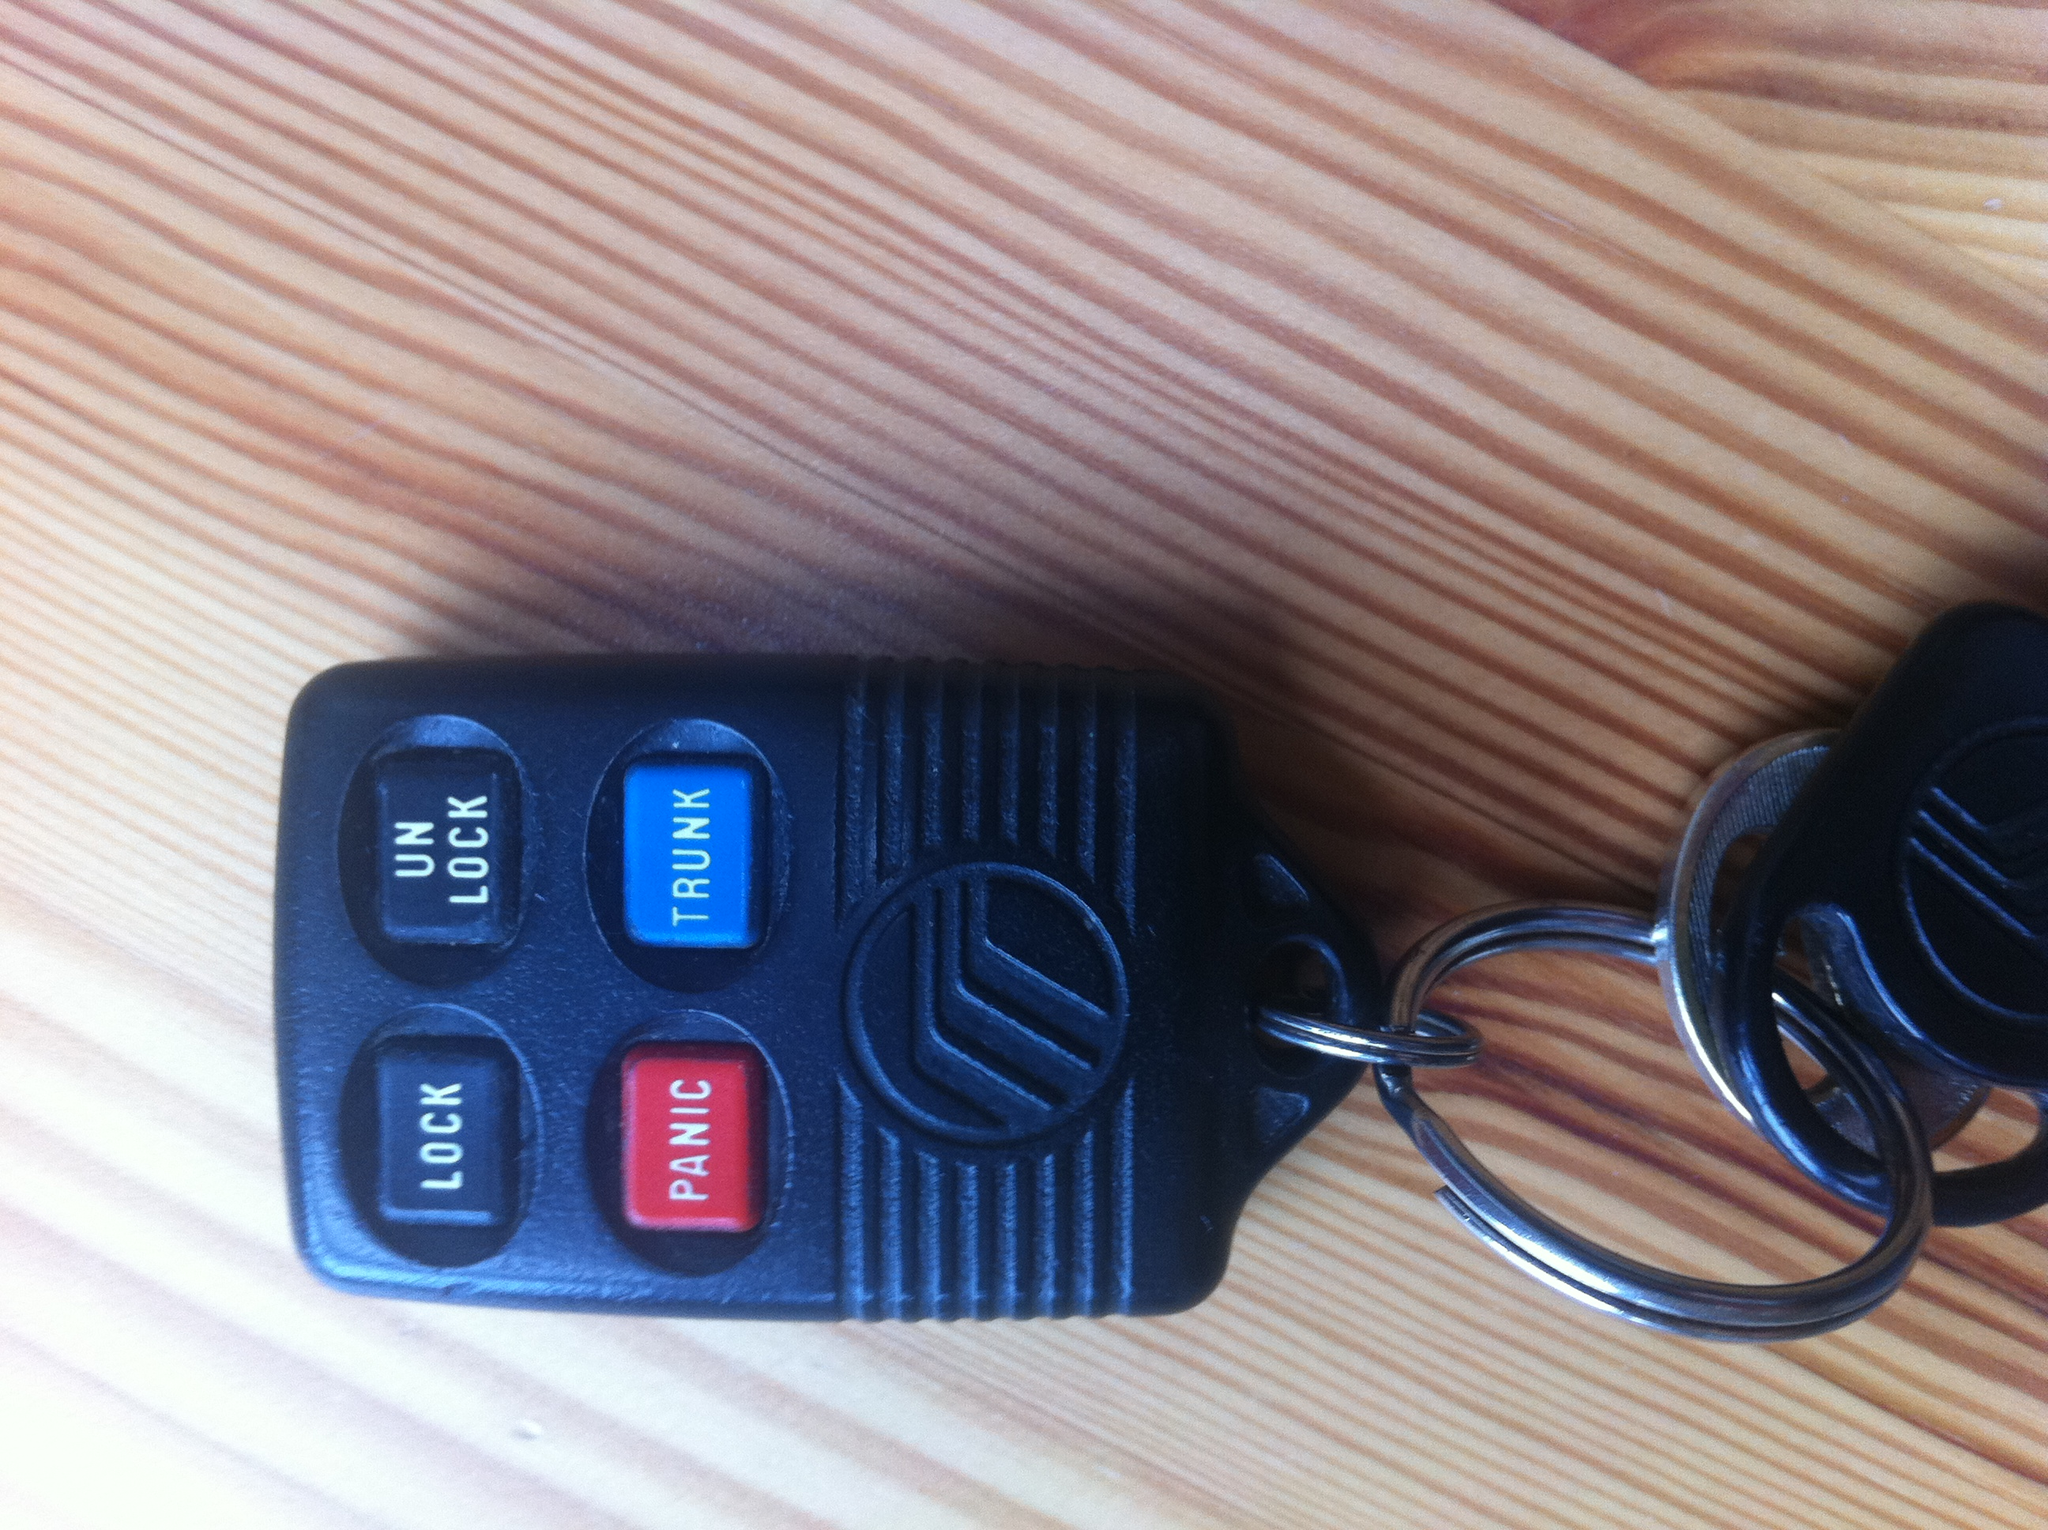Imagine these keys belong to a secret agent. How might the key's functions be different or enhanced? If these keys belonged to a secret agent, they might have additional hidden features. For example, the 'LOCK' button could deploy a security mechanism to immobilize the vehicle, the 'UNLOCK' button might disguise the vehicle with a camouflaging feature, the 'TRUNK' button could open to reveal a secret compartment for storing spy gadgets, and the 'PANIC' button might trigger a silent alarm to notify the agent's headquarters or create a smoke screen to obscure the agent's location. 